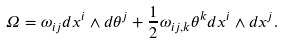<formula> <loc_0><loc_0><loc_500><loc_500>\Omega = \omega _ { i j } d x ^ { i } \wedge d \theta ^ { j } + \frac { 1 } { 2 } \omega _ { i j , k } \theta ^ { k } d x ^ { i } \wedge d x ^ { j } .</formula> 